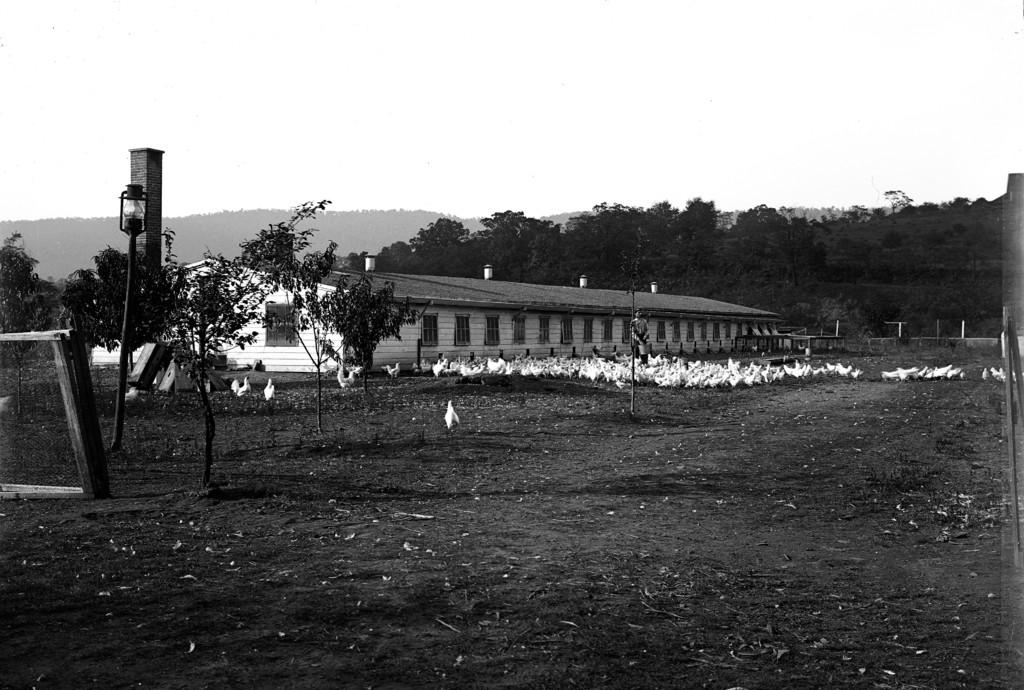Who or what is present in the image? There is a person in the image. What else can be seen on the ground in the image? There are birds on the ground in the image. What type of structure is visible in the image? There is a shed in the image. What type of natural elements are present in the image? There are trees in the image. What other items can be seen in the image? There are some objects in the image. What is visible in the background of the image? The sky is visible in the background of the image. What type of powder is being used to twist the blade in the image? There is no powder or blade present in the image. 